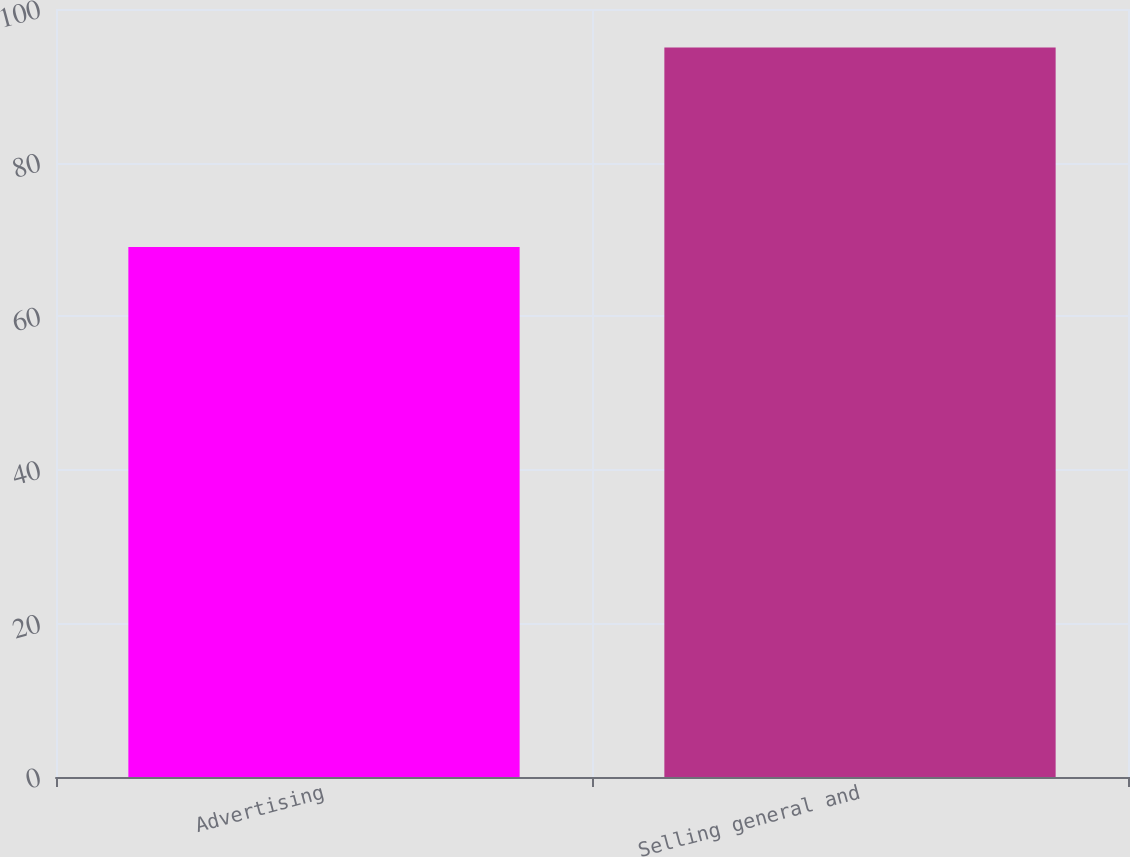Convert chart. <chart><loc_0><loc_0><loc_500><loc_500><bar_chart><fcel>Advertising<fcel>Selling general and<nl><fcel>69<fcel>95<nl></chart> 